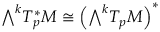<formula> <loc_0><loc_0><loc_500><loc_500>{ \bigwedge } ^ { k } T _ { p } ^ { * } M \cong { \left ( } { \bigwedge } ^ { k } T _ { p } M { \right ) } ^ { * }</formula> 